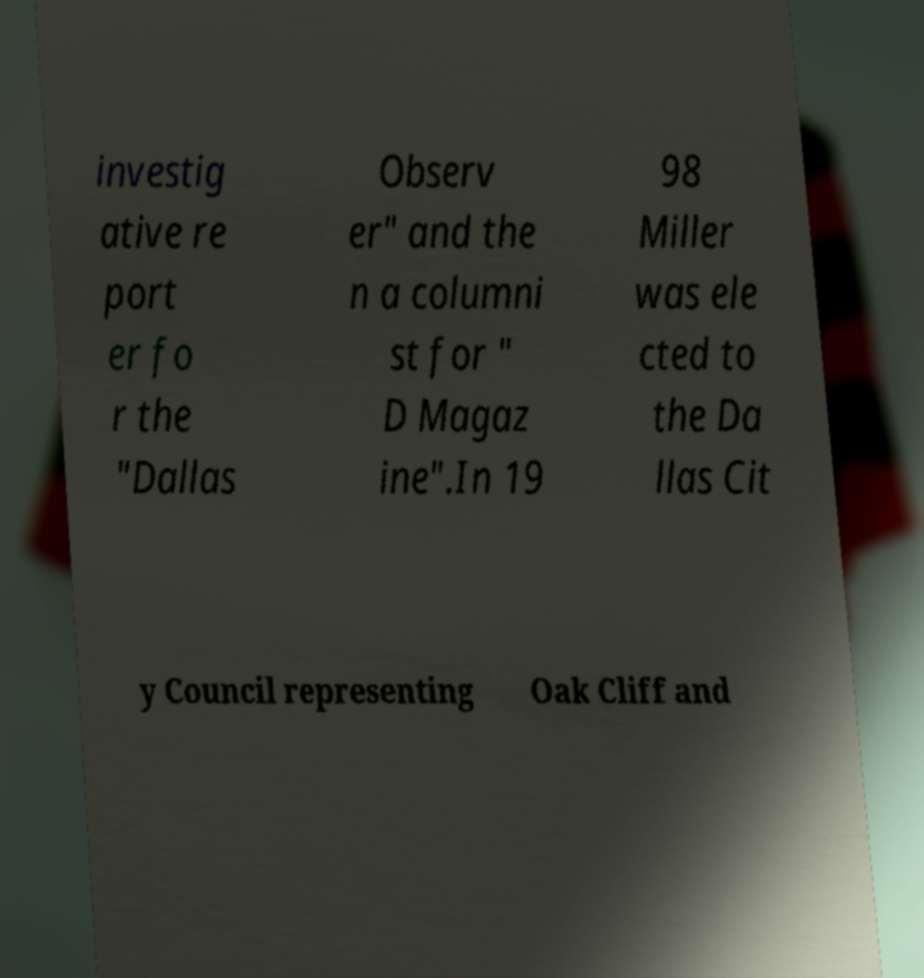Please identify and transcribe the text found in this image. investig ative re port er fo r the "Dallas Observ er" and the n a columni st for " D Magaz ine".In 19 98 Miller was ele cted to the Da llas Cit y Council representing Oak Cliff and 